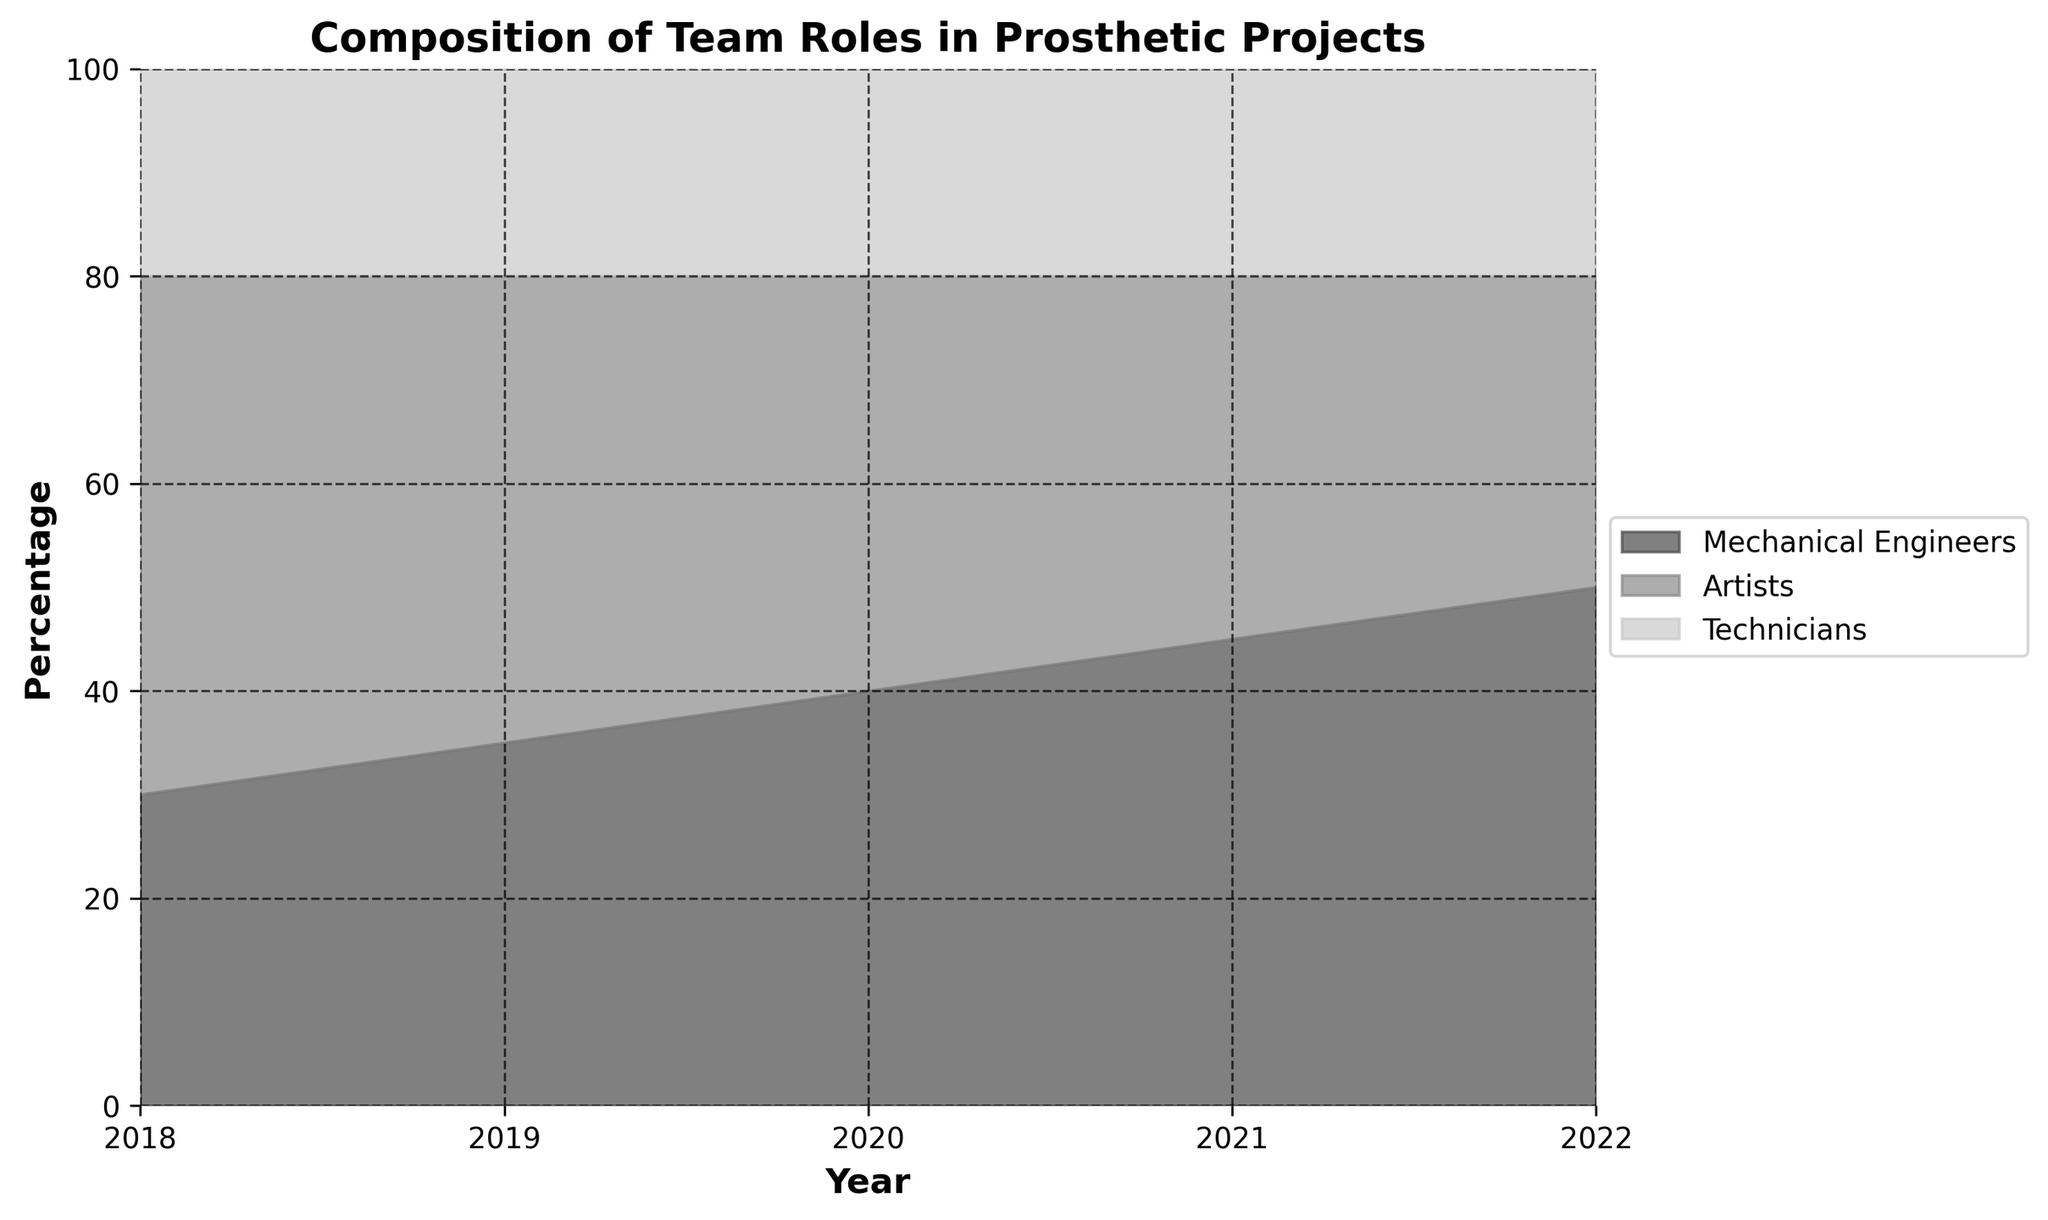What is the title of the plot? The title of the plot is usually located at the top of the chart, and it is meant to describe what the plot represents. In this case, reading the top of the plot should reveal the title.
Answer: Composition of Team Roles in Prosthetic Projects How many different categories of team roles are depicted in the chart? By looking at the legend or the different colored areas in the chart, one can count the distinct categories of team roles presented.
Answer: 3 In which year did the percentage of Mechanical Engineers start to be higher than the percentage of Artists? To answer this, observe the area representing Mechanical Engineers (likely the darkest shade) and compare when it surpasses the area for Artists (another distinct shade).
Answer: 2019 By how much did the percentage of Artists decrease from 2018 to 2022? To find the decrease, look at the percentage value for Artists in 2018 and subtract the percentage value in 2022. The Artists area is shown in the legend and the corresponding shade on the chart.
Answer: 20% Between which consecutive years was there the greatest increase in the percentage of Mechanical Engineers? Observe the increase in the shaded area for Mechanical Engineers between each pair of consecutive years, and pick the largest one.
Answer: 2021-2022 What is the percentage of Technicians in any given year? Since the technicians' percentage is constant every year, you can pick any year and look at the corresponding shaded area or check the plot legend/labels to find the percentage.
Answer: 20% Compare the total percentage of Mechanical Engineers and Artists together in 2020. What's the result? Sum the percentage of Mechanical Engineers and Artists in 2020 by finding their values on the chart or by using the percentages shown in the figure.
Answer: 80% Which team role has the steepest decline over the years observed? Identify the area that decreases most rapidly from left to right over the years. This can be done by observing the steepness of the line separating that category from the next.
Answer: Artists By what percentage did the proportion of Mechanical Engineers change from 2018 to 2022? Subtract the percentage of Mechanical Engineers in 2018 from their percentage in 2022 to determine the change.
Answer: 20% How does the representation of Technicians compare to the other roles each year? Technicians maintain a constant percentage, whereas the areas for Mechanical Engineers and Artists change each year. By checking each year's data, we can see technicians remain at 20% while others vary.
Answer: Constant, with 20% 